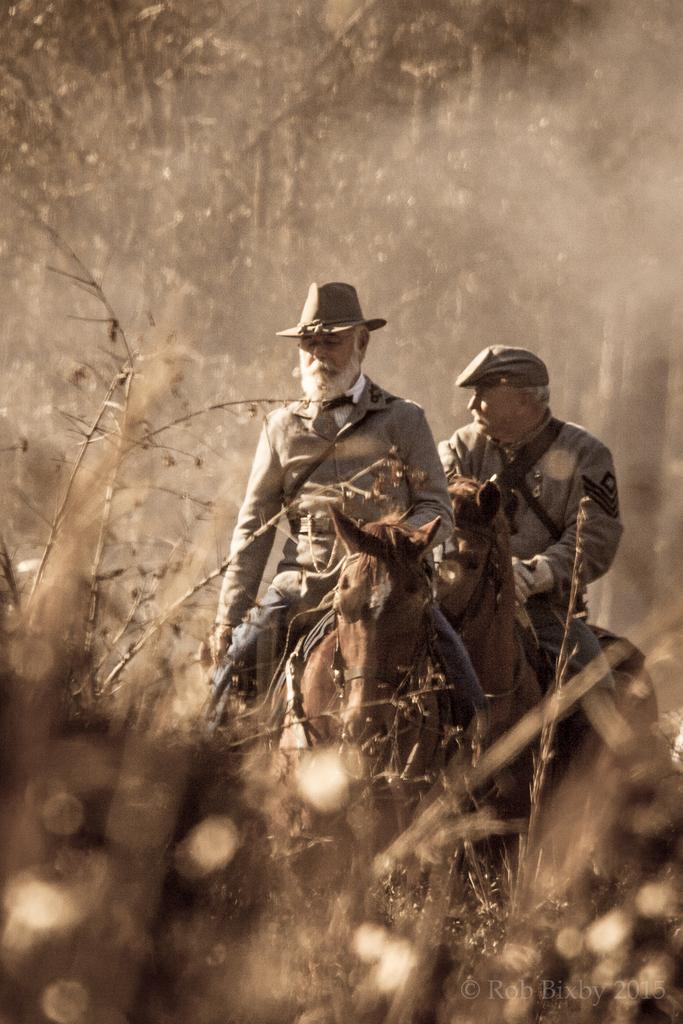What are the persons in the image doing? The persons in the image are sitting on horses. What type of clothing are the persons wearing? The persons are wearing jackets and hats. Where is the mailbox located in the image? There is no mailbox present in the image. What type of shade is provided for the persons in the image? There is no shade mentioned or visible in the image. 